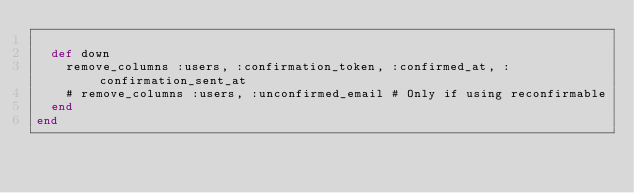<code> <loc_0><loc_0><loc_500><loc_500><_Ruby_>
  def down
    remove_columns :users, :confirmation_token, :confirmed_at, :confirmation_sent_at
    # remove_columns :users, :unconfirmed_email # Only if using reconfirmable
  end
end
</code> 